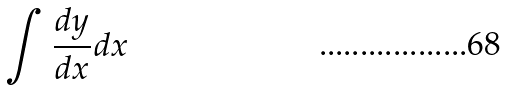<formula> <loc_0><loc_0><loc_500><loc_500>\int \frac { d y } { d x } d x</formula> 